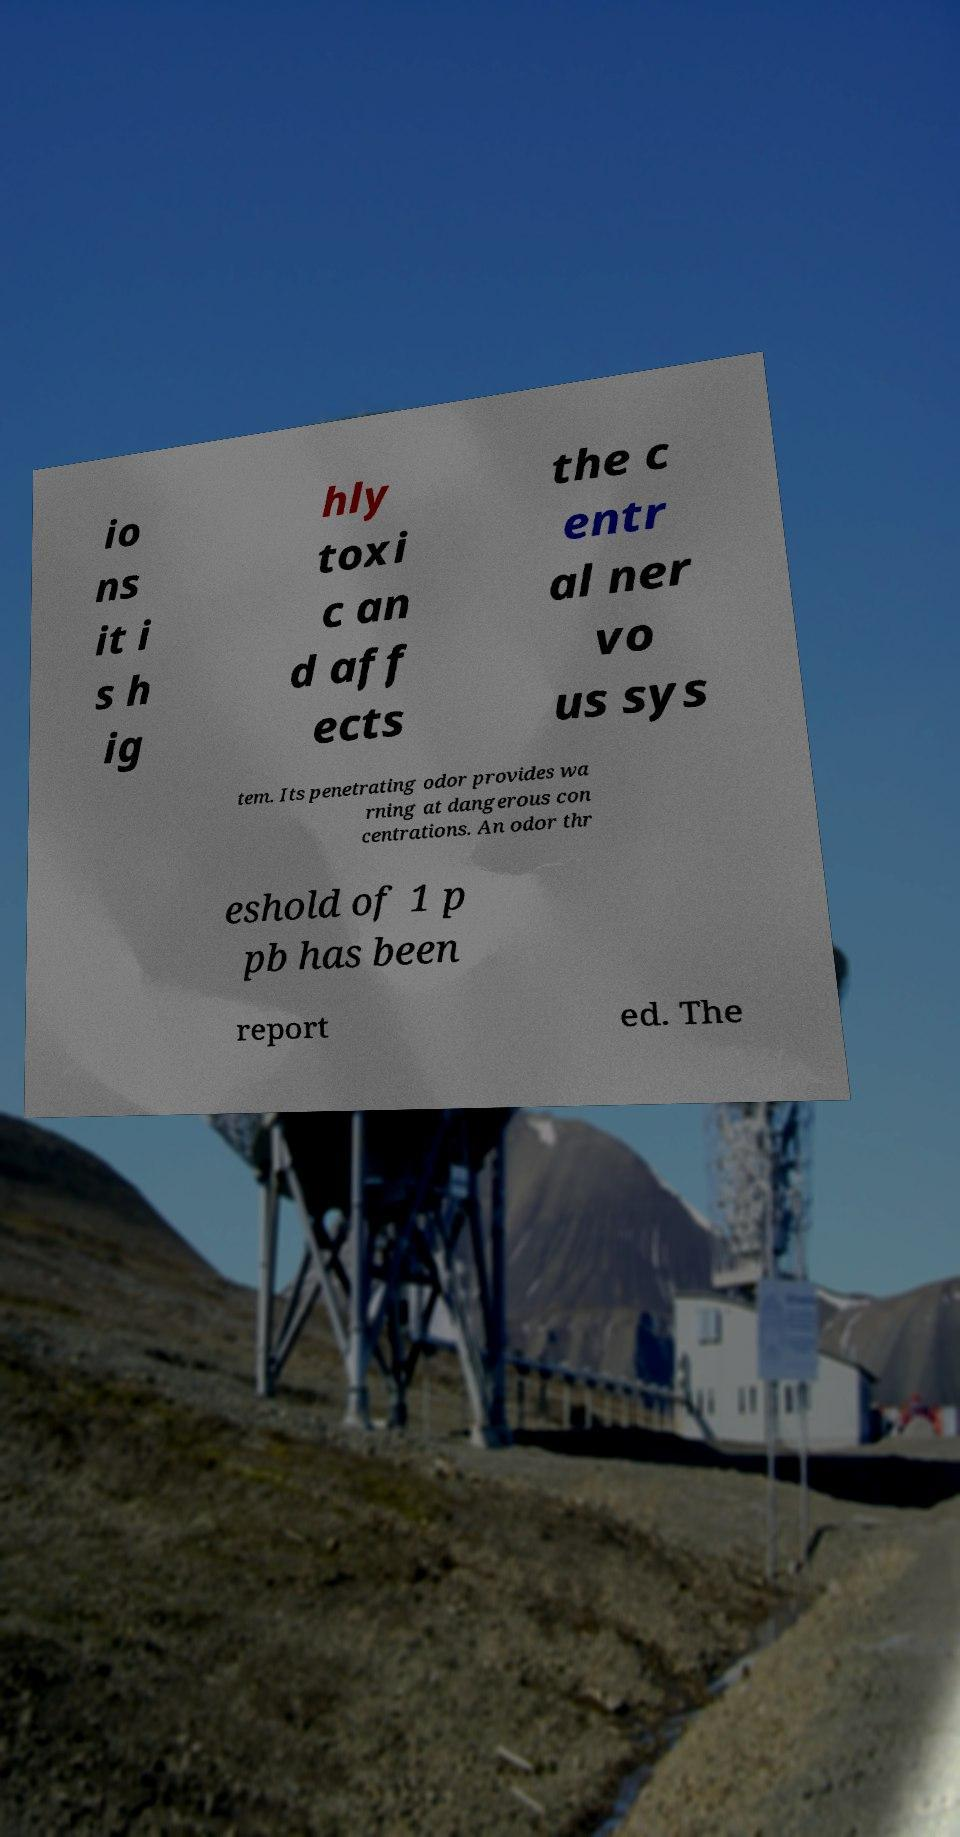Could you extract and type out the text from this image? io ns it i s h ig hly toxi c an d aff ects the c entr al ner vo us sys tem. Its penetrating odor provides wa rning at dangerous con centrations. An odor thr eshold of 1 p pb has been report ed. The 